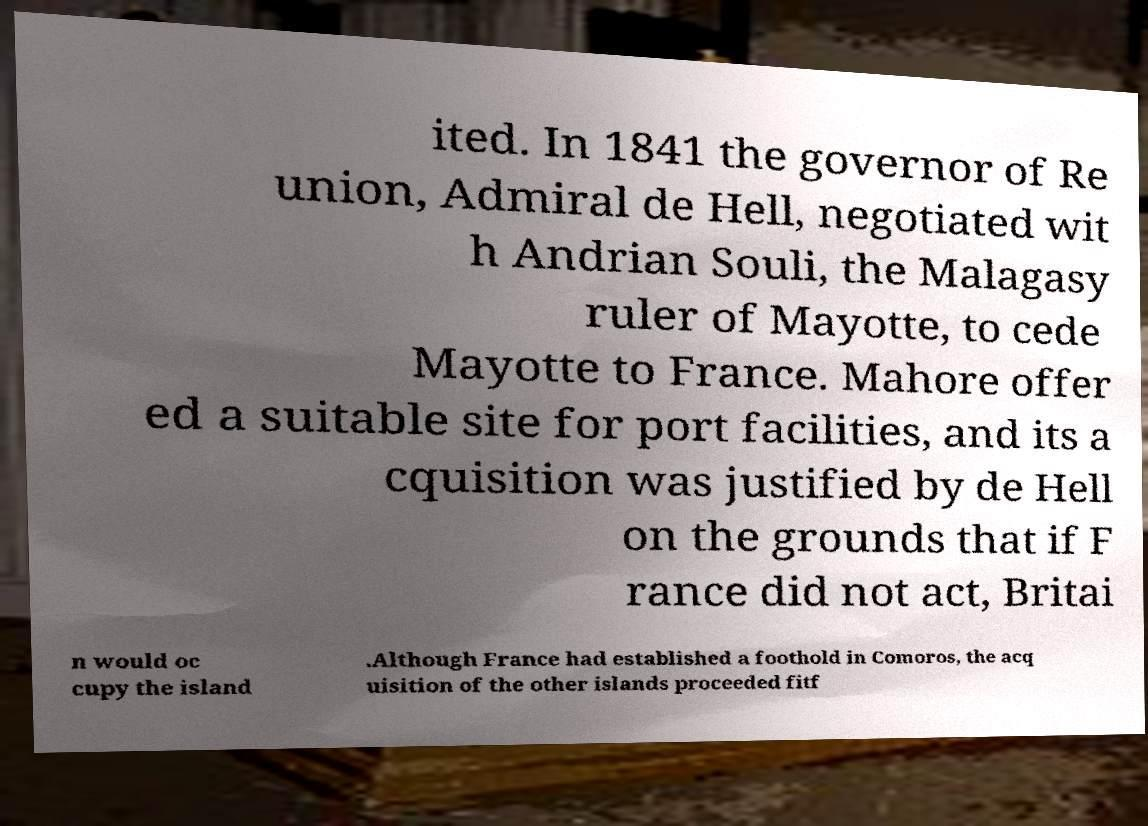Please identify and transcribe the text found in this image. ited. In 1841 the governor of Re union, Admiral de Hell, negotiated wit h Andrian Souli, the Malagasy ruler of Mayotte, to cede Mayotte to France. Mahore offer ed a suitable site for port facilities, and its a cquisition was justified by de Hell on the grounds that if F rance did not act, Britai n would oc cupy the island .Although France had established a foothold in Comoros, the acq uisition of the other islands proceeded fitf 